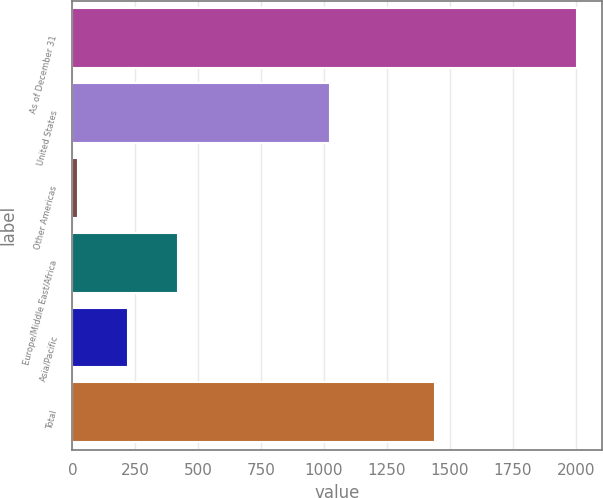Convert chart to OTSL. <chart><loc_0><loc_0><loc_500><loc_500><bar_chart><fcel>As of December 31<fcel>United States<fcel>Other Americas<fcel>Europe/Middle East/Africa<fcel>Asia/Pacific<fcel>Total<nl><fcel>2005<fcel>1023<fcel>24<fcel>420.2<fcel>222.1<fcel>1441<nl></chart> 